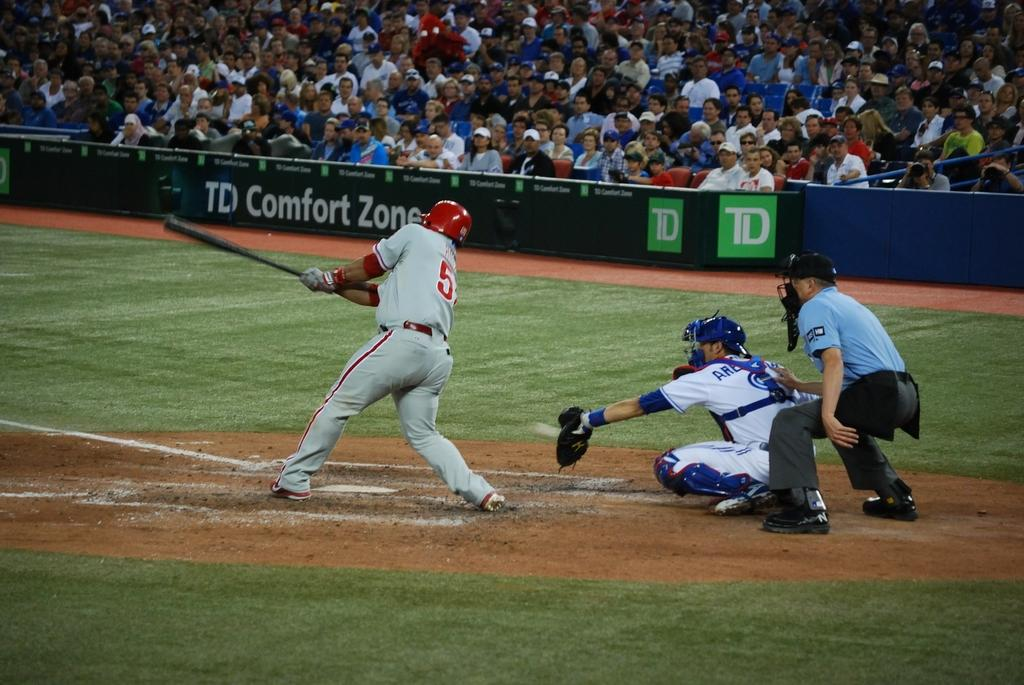<image>
Present a compact description of the photo's key features. A banner reads "TD Comfort Zone" at a baseball field. 